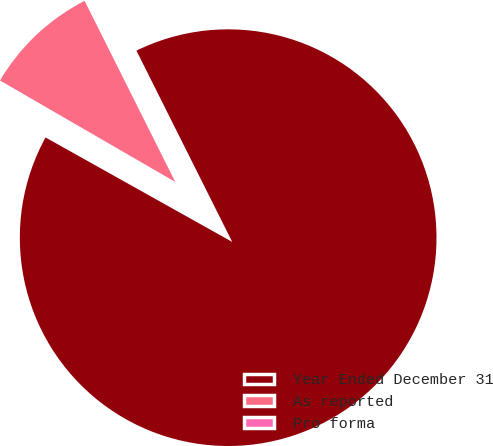Convert chart to OTSL. <chart><loc_0><loc_0><loc_500><loc_500><pie_chart><fcel>Year Ended December 31<fcel>As reported<fcel>Pro forma<nl><fcel>90.51%<fcel>9.26%<fcel>0.23%<nl></chart> 